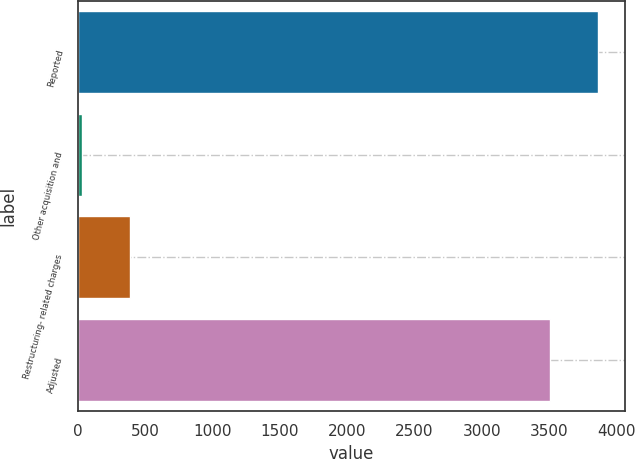Convert chart to OTSL. <chart><loc_0><loc_0><loc_500><loc_500><bar_chart><fcel>Reported<fcel>Other acquisition and<fcel>Restructuring- related charges<fcel>Adjusted<nl><fcel>3868.2<fcel>28<fcel>386.2<fcel>3510<nl></chart> 